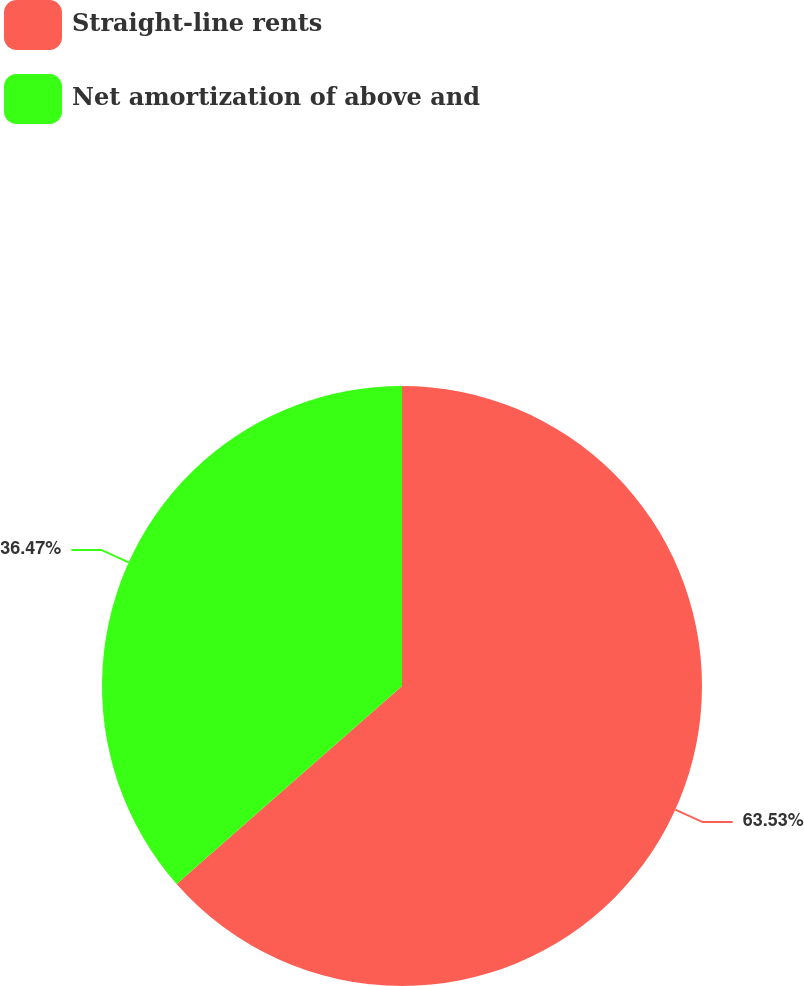Convert chart. <chart><loc_0><loc_0><loc_500><loc_500><pie_chart><fcel>Straight-line rents<fcel>Net amortization of above and<nl><fcel>63.53%<fcel>36.47%<nl></chart> 